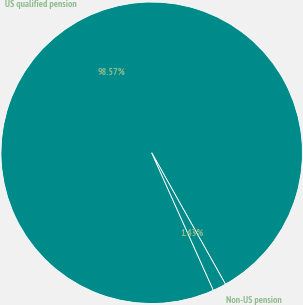Convert chart. <chart><loc_0><loc_0><loc_500><loc_500><pie_chart><fcel>US qualified pension<fcel>Non-US pension<nl><fcel>98.57%<fcel>1.43%<nl></chart> 